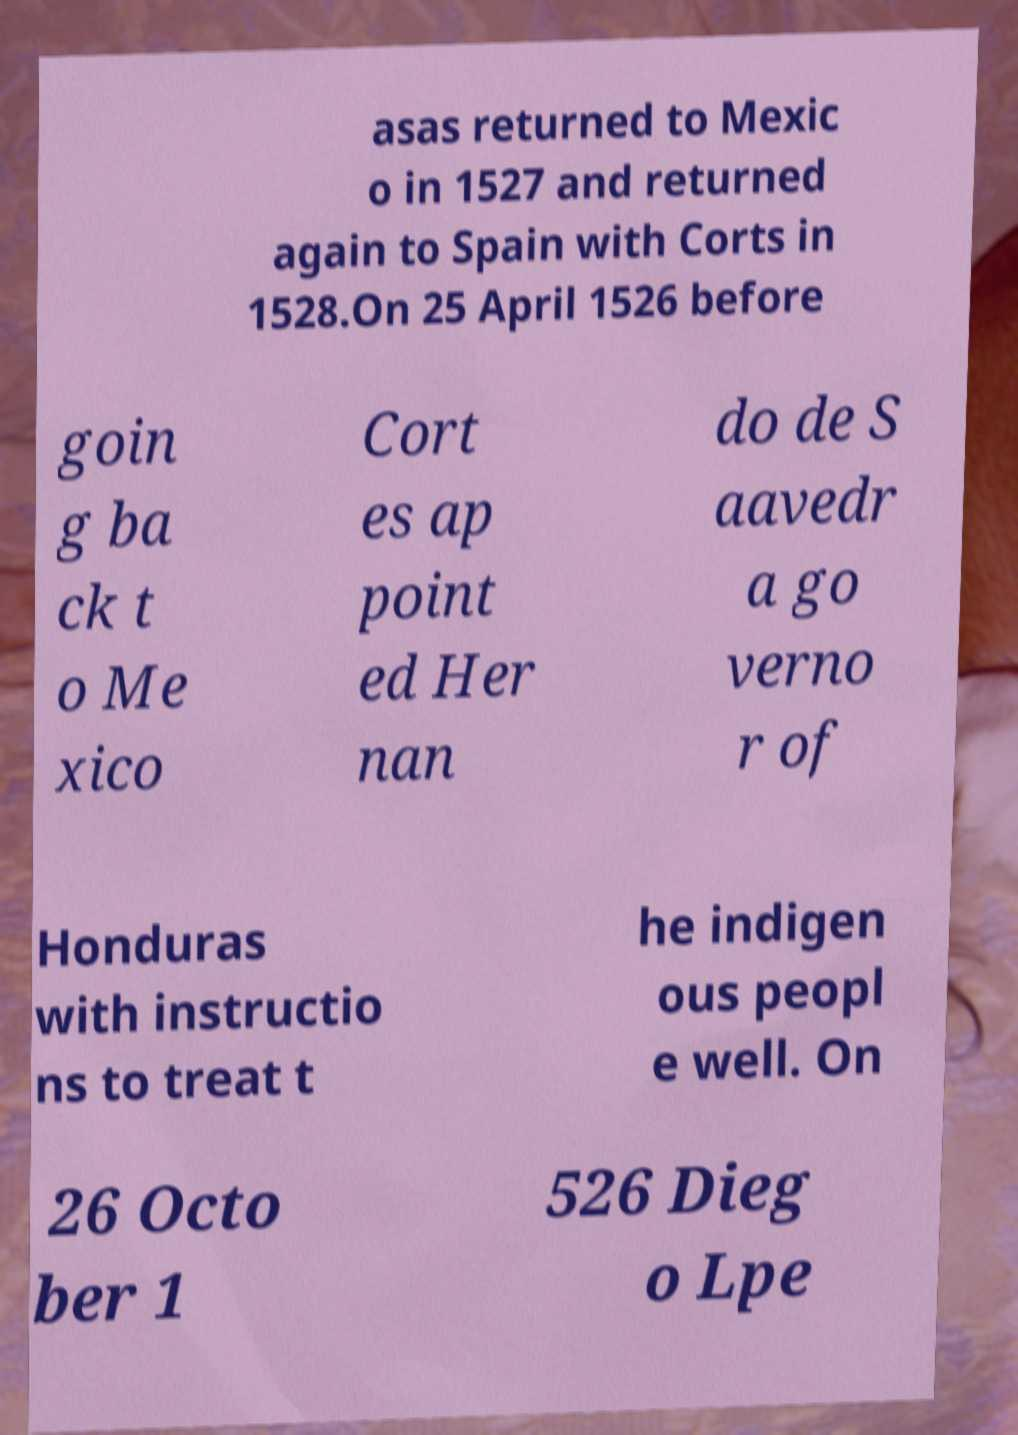Can you accurately transcribe the text from the provided image for me? asas returned to Mexic o in 1527 and returned again to Spain with Corts in 1528.On 25 April 1526 before goin g ba ck t o Me xico Cort es ap point ed Her nan do de S aavedr a go verno r of Honduras with instructio ns to treat t he indigen ous peopl e well. On 26 Octo ber 1 526 Dieg o Lpe 